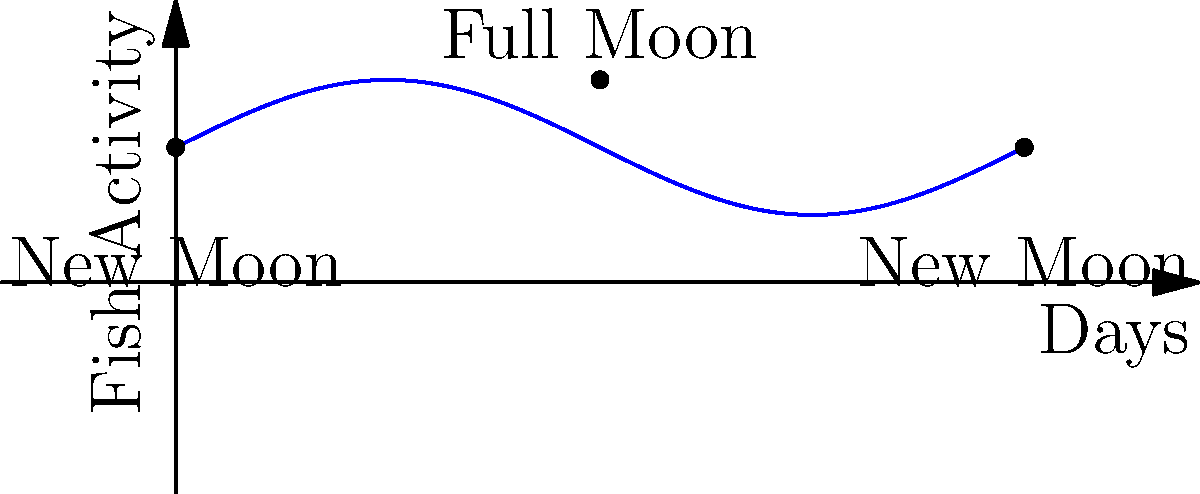As a fisherman, you know that fish activity is influenced by moon phases. The graph shows fish activity over a lunar cycle. If today is a new moon and you want to fish when activity is highest, how many days should you wait? To determine the optimal time for night fishing based on moon phases, we need to follow these steps:

1. Understand the graph:
   - The x-axis represents days in a lunar cycle (about 29.5 days).
   - The y-axis represents fish activity.
   - The curve shows how fish activity changes over the lunar cycle.

2. Identify key points:
   - New moon is at day 0 and day 29.5 (shown as 2π on the graph).
   - Full moon is in the middle of the cycle, at day 14.75 (shown as π on the graph).

3. Locate the peak of fish activity:
   - The highest point on the curve corresponds to the full moon.
   - This is where fish activity is maximum.

4. Calculate the time to wait:
   - From the new moon (day 0) to the full moon (day 14.75) is half of the lunar cycle.
   - Half of 29.5 days is 14.75 days.

Therefore, to fish when activity is highest, you should wait approximately 14.75 days from the new moon.
Answer: 14.75 days 